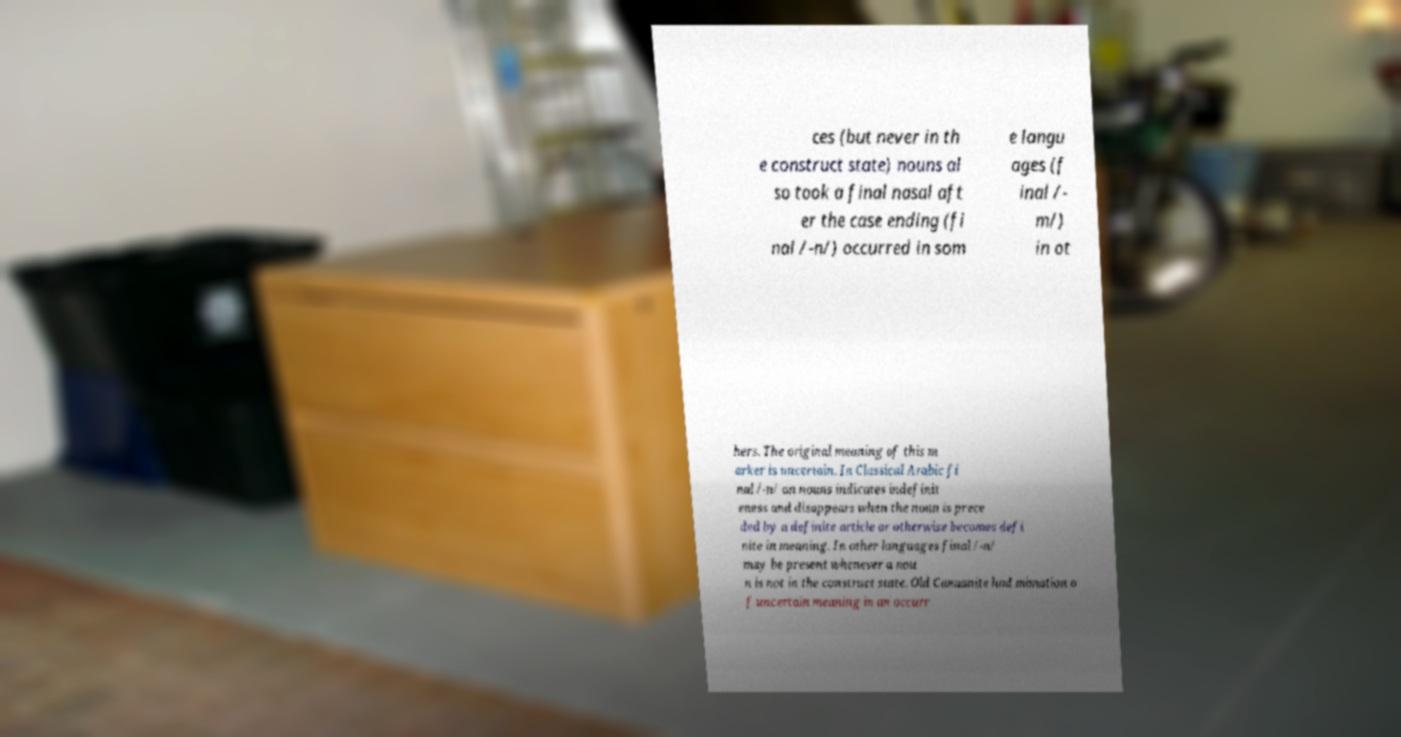Can you read and provide the text displayed in the image?This photo seems to have some interesting text. Can you extract and type it out for me? ces (but never in th e construct state) nouns al so took a final nasal aft er the case ending (fi nal /-n/) occurred in som e langu ages (f inal /- m/) in ot hers. The original meaning of this m arker is uncertain. In Classical Arabic fi nal /-n/ on nouns indicates indefinit eness and disappears when the noun is prece ded by a definite article or otherwise becomes defi nite in meaning. In other languages final /-n/ may be present whenever a nou n is not in the construct state. Old Canaanite had mimation o f uncertain meaning in an occurr 